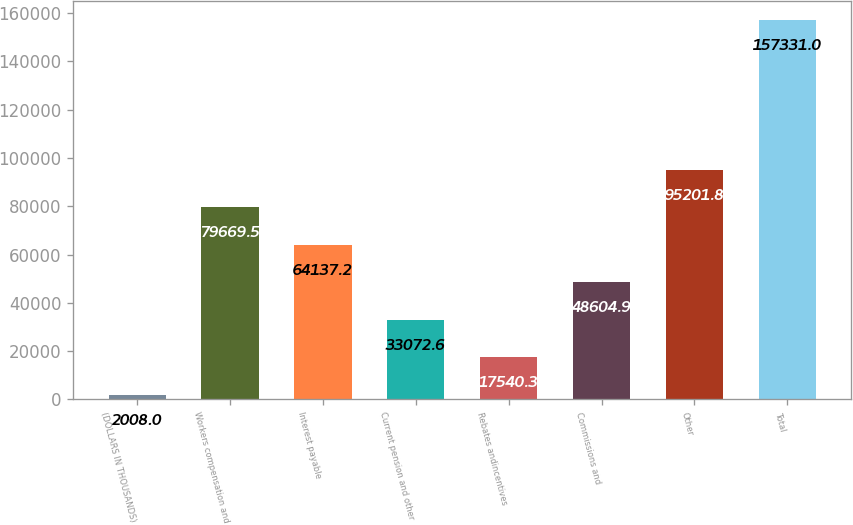<chart> <loc_0><loc_0><loc_500><loc_500><bar_chart><fcel>(DOLLARS IN THOUSANDS)<fcel>Workers compensation and<fcel>Interest payable<fcel>Current pension and other<fcel>Rebates andincentives<fcel>Commissions and<fcel>Other<fcel>Total<nl><fcel>2008<fcel>79669.5<fcel>64137.2<fcel>33072.6<fcel>17540.3<fcel>48604.9<fcel>95201.8<fcel>157331<nl></chart> 